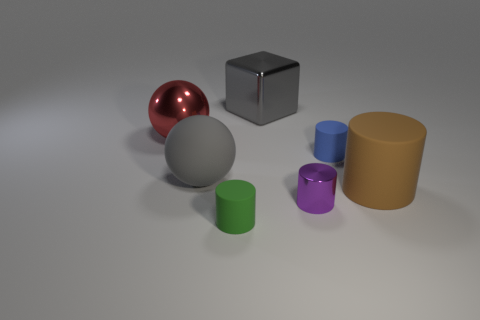Is the big metallic block the same color as the rubber sphere?
Your answer should be very brief. Yes. The large metal object that is the same color as the large matte sphere is what shape?
Give a very brief answer. Cube. Are there more big gray shiny cubes that are right of the small shiny cylinder than red metal things that are in front of the green rubber cylinder?
Your answer should be very brief. No. The gray sphere that is made of the same material as the small blue thing is what size?
Your response must be concise. Large. What number of large brown matte cylinders are on the right side of the tiny matte cylinder that is behind the large brown cylinder?
Provide a succinct answer. 1. Is there a gray metallic thing that has the same shape as the red object?
Offer a terse response. No. What color is the tiny metallic object that is behind the tiny rubber thing left of the tiny blue cylinder?
Offer a terse response. Purple. Is the number of small purple things greater than the number of big matte objects?
Make the answer very short. No. How many green matte objects are the same size as the purple metal cylinder?
Offer a terse response. 1. Does the big gray block have the same material as the gray object that is left of the tiny green thing?
Provide a succinct answer. No. 